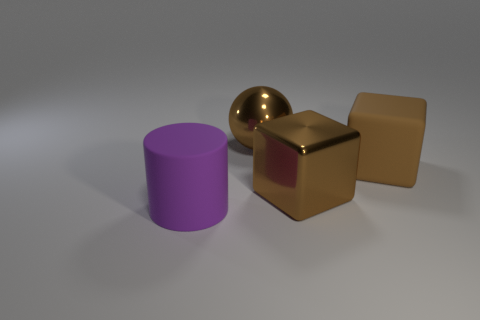Add 4 gray metallic objects. How many objects exist? 8 Subtract all spheres. How many objects are left? 3 Subtract 0 red cylinders. How many objects are left? 4 Subtract all big objects. Subtract all small cyan blocks. How many objects are left? 0 Add 3 large cubes. How many large cubes are left? 5 Add 1 large brown metallic blocks. How many large brown metallic blocks exist? 2 